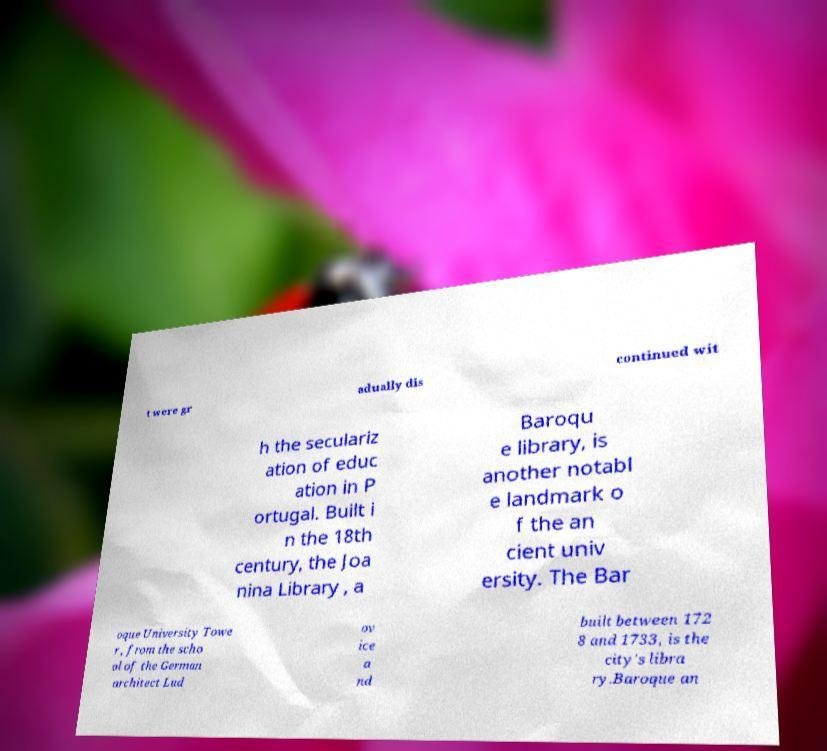Could you extract and type out the text from this image? t were gr adually dis continued wit h the seculariz ation of educ ation in P ortugal. Built i n the 18th century, the Joa nina Library , a Baroqu e library, is another notabl e landmark o f the an cient univ ersity. The Bar oque University Towe r , from the scho ol of the German architect Lud ov ice a nd built between 172 8 and 1733, is the city's libra ry.Baroque an 